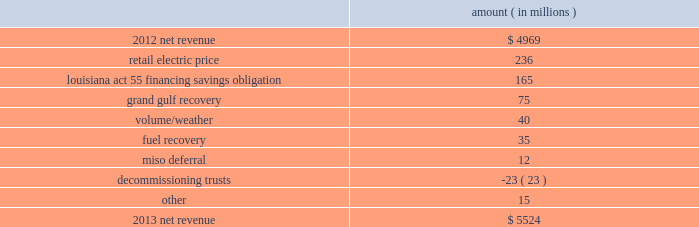Net revenue utility following is an analysis of the change in net revenue comparing 2013 to 2012 .
Amount ( in millions ) .
The retail electric price variance is primarily due to : 2022 a formula rate plan increase at entergy louisiana , effective january 2013 , which includes an increase relating to the waterford 3 steam generator replacement project , which was placed in service in december 2012 .
The net income effect of the formula rate plan increase is limited to a portion representing an allowed return on equity with the remainder offset by costs included in other operation and maintenance expenses , depreciation expenses , and taxes other than income taxes ; 2022 the recovery of hinds plant costs through the power management rider at entergy mississippi , as approved by the mpsc , effective with the first billing cycle of 2013 .
The net income effect of the hinds plant cost recovery is limited to a portion representing an allowed return on equity on the net plant investment with the remainder offset by the hinds plant costs in other operation and maintenance expenses , depreciation expenses , and taxes other than income taxes ; 2022 an increase in the capacity acquisition rider at entergy arkansas , as approved by the apsc , effective with the first billing cycle of december 2012 , relating to the hot spring plant acquisition .
The net income effect of the hot spring plant cost recovery is limited to a portion representing an allowed return on equity on the net plant investment with the remainder offset by the hot spring plant costs in other operation and maintenance expenses , depreciation expenses , and taxes other than income taxes ; 2022 increases in the energy efficiency rider , as approved by the apsc , effective july 2013 and july 2012 .
Energy efficiency revenues are offset by costs included in other operation and maintenance expenses and have no effect on net income ; 2022 an annual base rate increase at entergy texas , effective july 2012 , as a result of the puct 2019s order that was issued in september 2012 in the november 2011 rate case ; and 2022 a formula rate plan increase at entergy mississippi , effective september 2013 .
See note 2 to the financial statements for a discussion of rate proceedings .
The louisiana act 55 financing savings obligation variance results from a regulatory charge recorded in the second quarter 2012 because entergy gulf states louisiana and entergy louisiana agreed to share with customers the savings from an irs settlement related to the uncertain tax position regarding the hurricane katrina and hurricane rita louisiana act 55 financing .
See note 3 to the financial statements for additional discussion of the tax settlement .
Entergy corporation and subsidiaries management's financial discussion and analysis .
What percentage of the change in net revenue between 2012 and 2013 is due to retail electric price changes? 
Computations: (236 / (5524 - 4969))
Answer: 0.42523. 